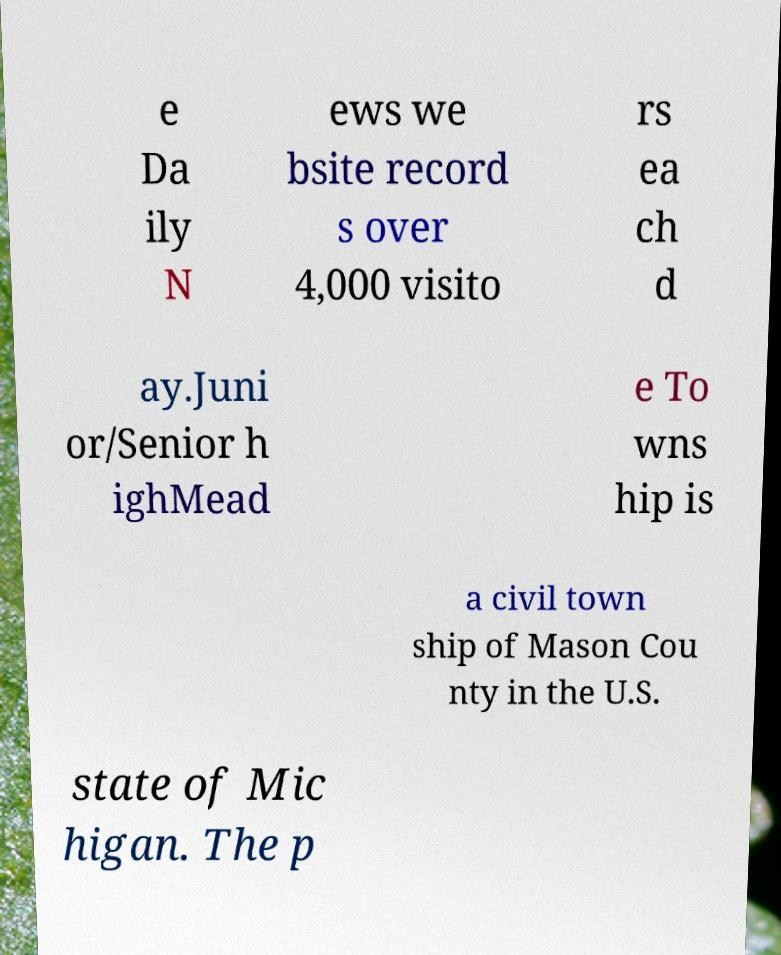For documentation purposes, I need the text within this image transcribed. Could you provide that? e Da ily N ews we bsite record s over 4,000 visito rs ea ch d ay.Juni or/Senior h ighMead e To wns hip is a civil town ship of Mason Cou nty in the U.S. state of Mic higan. The p 